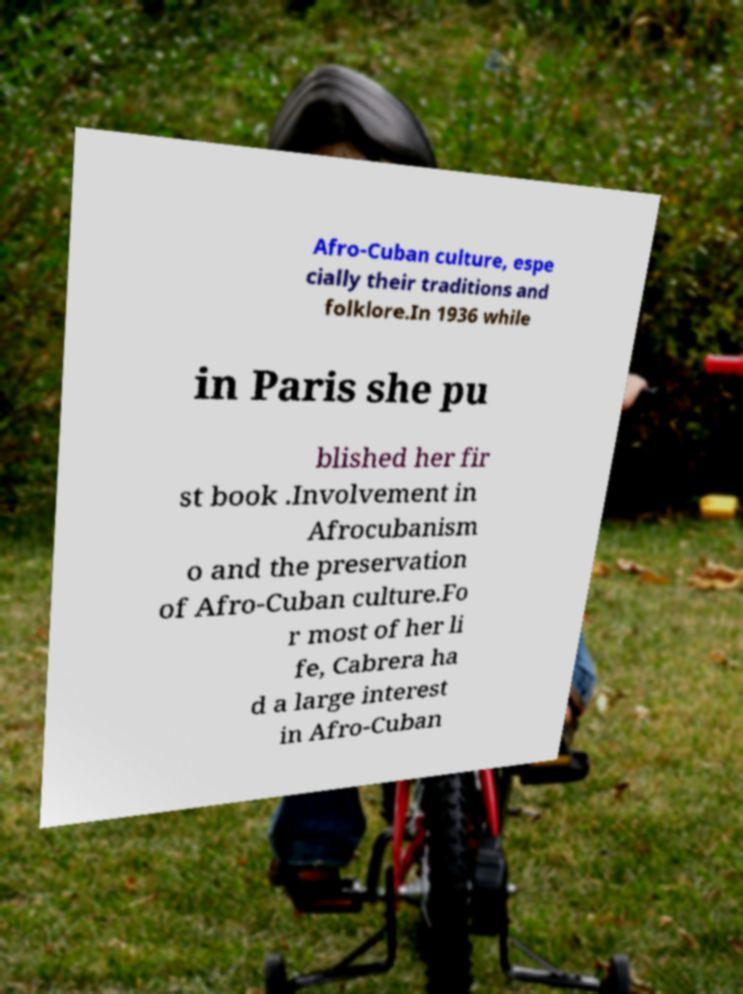I need the written content from this picture converted into text. Can you do that? Afro-Cuban culture, espe cially their traditions and folklore.In 1936 while in Paris she pu blished her fir st book .Involvement in Afrocubanism o and the preservation of Afro-Cuban culture.Fo r most of her li fe, Cabrera ha d a large interest in Afro-Cuban 